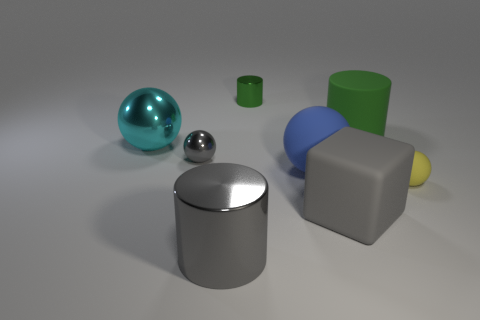What number of green cylinders are right of the tiny green object and to the left of the large green matte cylinder?
Make the answer very short. 0. There is a green thing right of the small cylinder; is its size the same as the metal cylinder in front of the large rubber cube?
Offer a terse response. Yes. How big is the gray shiny object behind the big shiny cylinder?
Your answer should be very brief. Small. What number of objects are gray objects that are on the right side of the small green cylinder or things that are behind the tiny yellow matte ball?
Ensure brevity in your answer.  6. Is there any other thing that is the same color as the big block?
Offer a very short reply. Yes. Is the number of gray spheres that are behind the big green object the same as the number of tiny green things in front of the large rubber sphere?
Provide a short and direct response. Yes. Are there more large gray metal cylinders that are on the left side of the big metal sphere than shiny objects?
Provide a succinct answer. No. How many things are objects that are to the left of the large gray cylinder or large blue balls?
Offer a very short reply. 3. How many big cylinders are made of the same material as the large cyan sphere?
Provide a succinct answer. 1. What shape is the metallic thing that is the same color as the tiny metallic ball?
Offer a very short reply. Cylinder. 